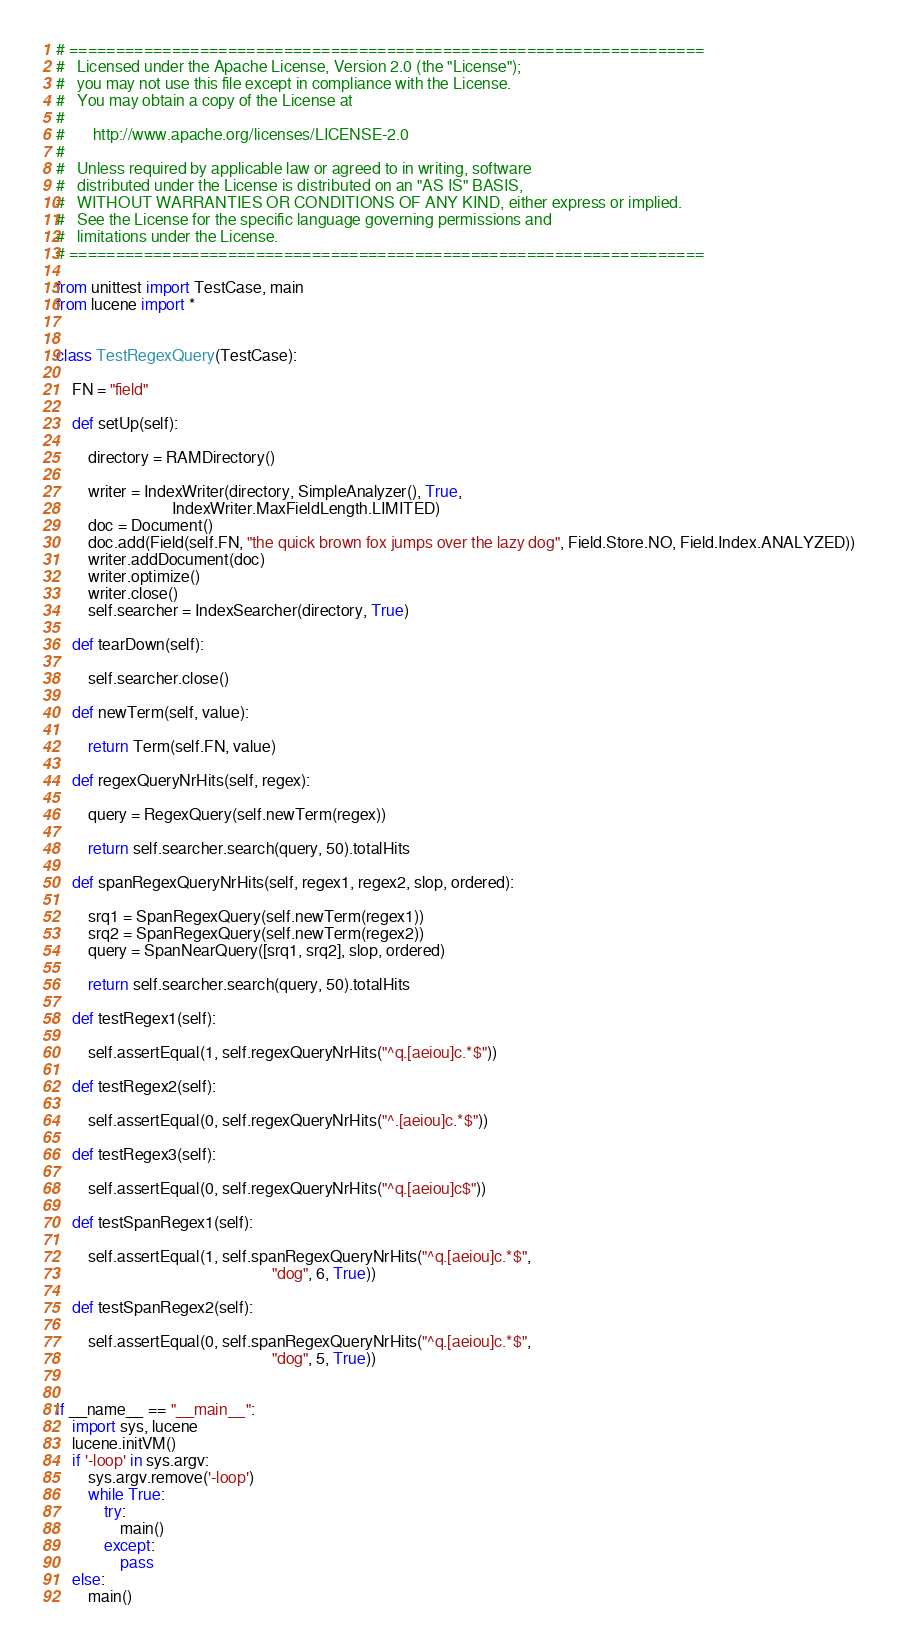Convert code to text. <code><loc_0><loc_0><loc_500><loc_500><_Python_># ====================================================================
#   Licensed under the Apache License, Version 2.0 (the "License");
#   you may not use this file except in compliance with the License.
#   You may obtain a copy of the License at
#
#       http://www.apache.org/licenses/LICENSE-2.0
#
#   Unless required by applicable law or agreed to in writing, software
#   distributed under the License is distributed on an "AS IS" BASIS,
#   WITHOUT WARRANTIES OR CONDITIONS OF ANY KIND, either express or implied.
#   See the License for the specific language governing permissions and
#   limitations under the License.
# ====================================================================

from unittest import TestCase, main
from lucene import *


class TestRegexQuery(TestCase):

    FN = "field"

    def setUp(self):

        directory = RAMDirectory()

        writer = IndexWriter(directory, SimpleAnalyzer(), True,
                             IndexWriter.MaxFieldLength.LIMITED)
        doc = Document()
        doc.add(Field(self.FN, "the quick brown fox jumps over the lazy dog", Field.Store.NO, Field.Index.ANALYZED))
        writer.addDocument(doc)
        writer.optimize()
        writer.close()
        self.searcher = IndexSearcher(directory, True)

    def tearDown(self):

        self.searcher.close()

    def newTerm(self, value):
  
        return Term(self.FN, value)

    def regexQueryNrHits(self, regex):

        query = RegexQuery(self.newTerm(regex))

        return self.searcher.search(query, 50).totalHits

    def spanRegexQueryNrHits(self, regex1, regex2, slop, ordered):

        srq1 = SpanRegexQuery(self.newTerm(regex1))
        srq2 = SpanRegexQuery(self.newTerm(regex2))
        query = SpanNearQuery([srq1, srq2], slop, ordered)

        return self.searcher.search(query, 50).totalHits

    def testRegex1(self):

        self.assertEqual(1, self.regexQueryNrHits("^q.[aeiou]c.*$"))

    def testRegex2(self):

        self.assertEqual(0, self.regexQueryNrHits("^.[aeiou]c.*$"))

    def testRegex3(self):

        self.assertEqual(0, self.regexQueryNrHits("^q.[aeiou]c$"))

    def testSpanRegex1(self):

        self.assertEqual(1, self.spanRegexQueryNrHits("^q.[aeiou]c.*$",
                                                      "dog", 6, True))

    def testSpanRegex2(self):

        self.assertEqual(0, self.spanRegexQueryNrHits("^q.[aeiou]c.*$",
                                                      "dog", 5, True))


if __name__ == "__main__":
    import sys, lucene
    lucene.initVM()
    if '-loop' in sys.argv:
        sys.argv.remove('-loop')
        while True:
            try:
                main()
            except:
                pass
    else:
        main()
</code> 